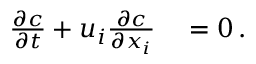<formula> <loc_0><loc_0><loc_500><loc_500>\begin{array} { r l } { \frac { \partial c } { \partial t } + u _ { i } \frac { \partial c } { \partial x _ { i } } } & = 0 \, . } \end{array}</formula> 